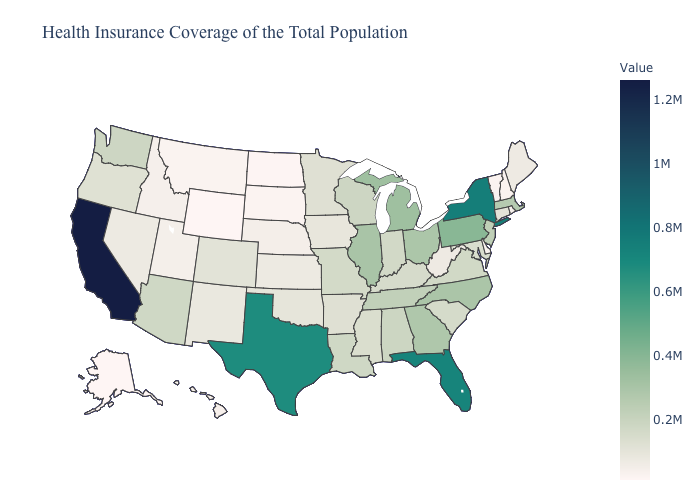Does Wyoming have the lowest value in the USA?
Concise answer only. Yes. Among the states that border Wisconsin , does Iowa have the lowest value?
Short answer required. Yes. Which states have the lowest value in the USA?
Give a very brief answer. Wyoming. Among the states that border Rhode Island , which have the highest value?
Keep it brief. Massachusetts. Does Montana have the lowest value in the West?
Write a very short answer. No. 